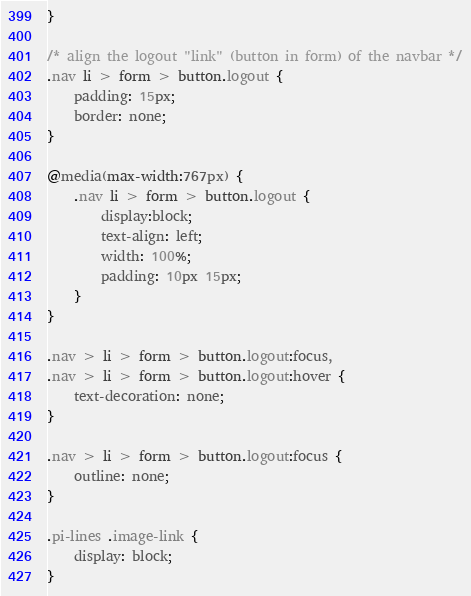<code> <loc_0><loc_0><loc_500><loc_500><_CSS_>}

/* align the logout "link" (button in form) of the navbar */
.nav li > form > button.logout {
    padding: 15px;
    border: none;
}

@media(max-width:767px) {
    .nav li > form > button.logout {
        display:block;
        text-align: left;
        width: 100%;
        padding: 10px 15px;
    }
}

.nav > li > form > button.logout:focus,
.nav > li > form > button.logout:hover {
    text-decoration: none;
}

.nav > li > form > button.logout:focus {
    outline: none;
}

.pi-lines .image-link {
    display: block;
}
</code> 